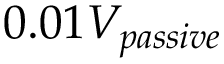Convert formula to latex. <formula><loc_0><loc_0><loc_500><loc_500>0 . 0 1 V _ { p a s s i v e }</formula> 